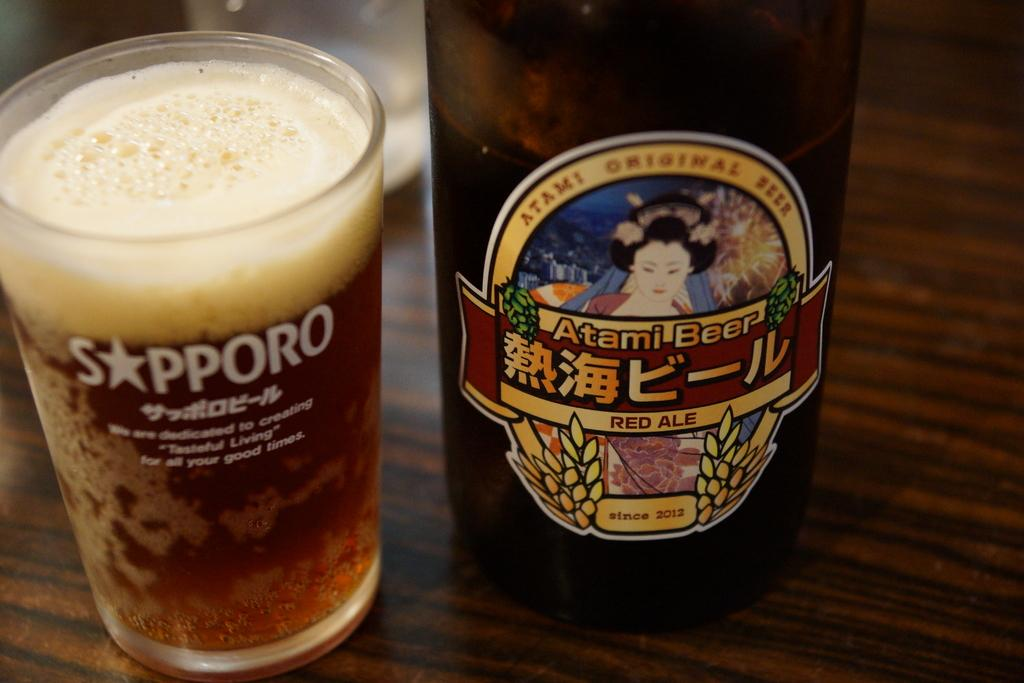<image>
Create a compact narrative representing the image presented. A glass of atami beer in a sapporo glass 